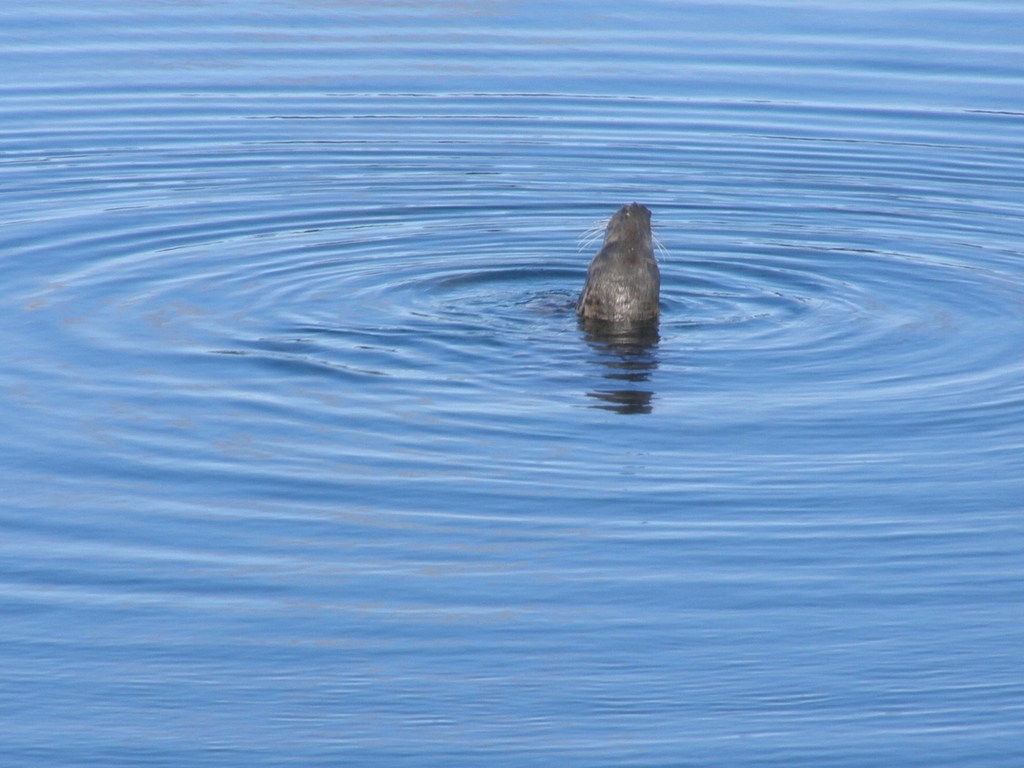What can be seen in the background of the image?
A. Mountains in the distance
B. Buildings on the shore
C. Clouds in the sky
D. Ripples on the water surface
Answer with the option's letter from the given choices directly.
 D. 